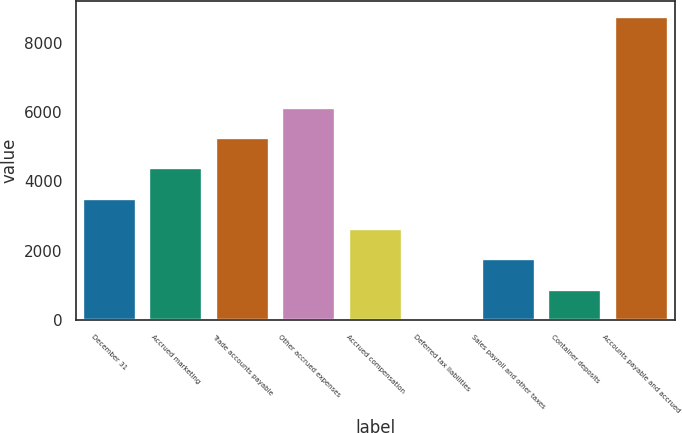<chart> <loc_0><loc_0><loc_500><loc_500><bar_chart><fcel>December 31<fcel>Accrued marketing<fcel>Trade accounts payable<fcel>Other accrued expenses<fcel>Accrued compensation<fcel>Deferred tax liabilities<fcel>Sales payroll and other taxes<fcel>Container deposits<fcel>Accounts payable and accrued<nl><fcel>3499.8<fcel>4374.5<fcel>5249.2<fcel>6123.9<fcel>2625.1<fcel>1<fcel>1750.4<fcel>875.7<fcel>8748<nl></chart> 